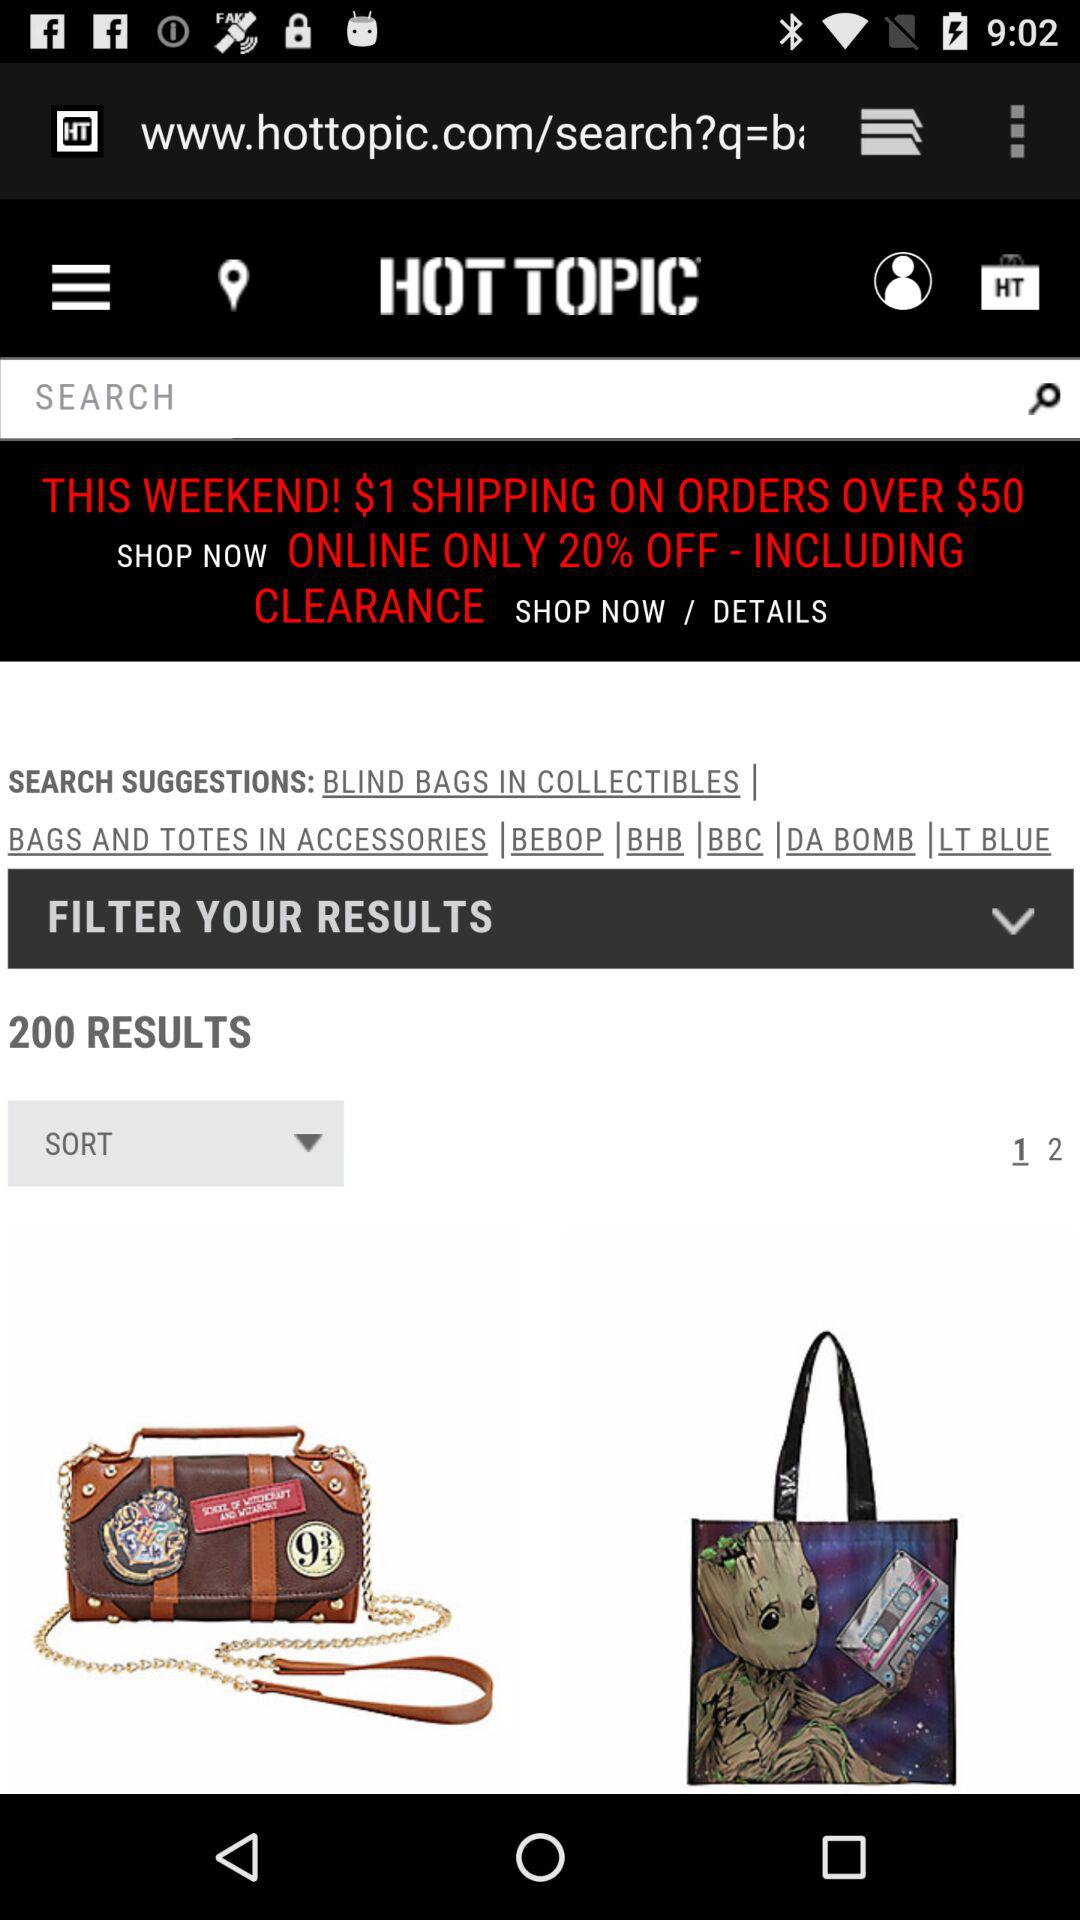How many pages are available on the screen? There are 2 pages available on the screen. 